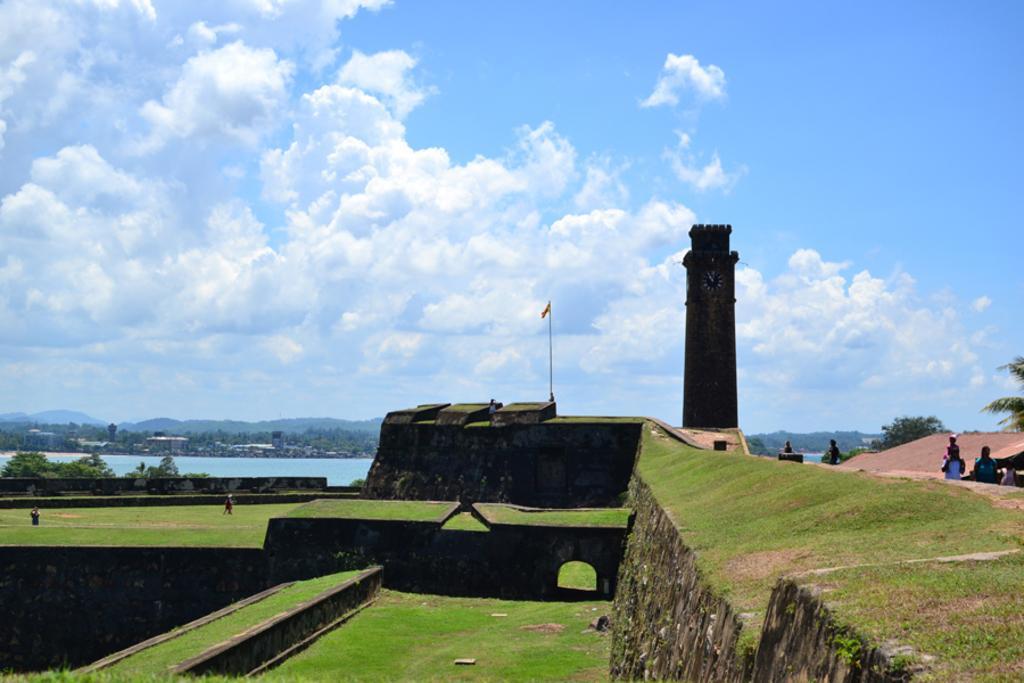Can you describe this image briefly? In the image we can see there is a clock tower, beside there is a flag which is kept on the building and the ground is covered with grass. People are sitting on the benches and others are standing on the ground. Behind there is a lake and there are lot of trees and buildings. There is a clear sky on the top. 